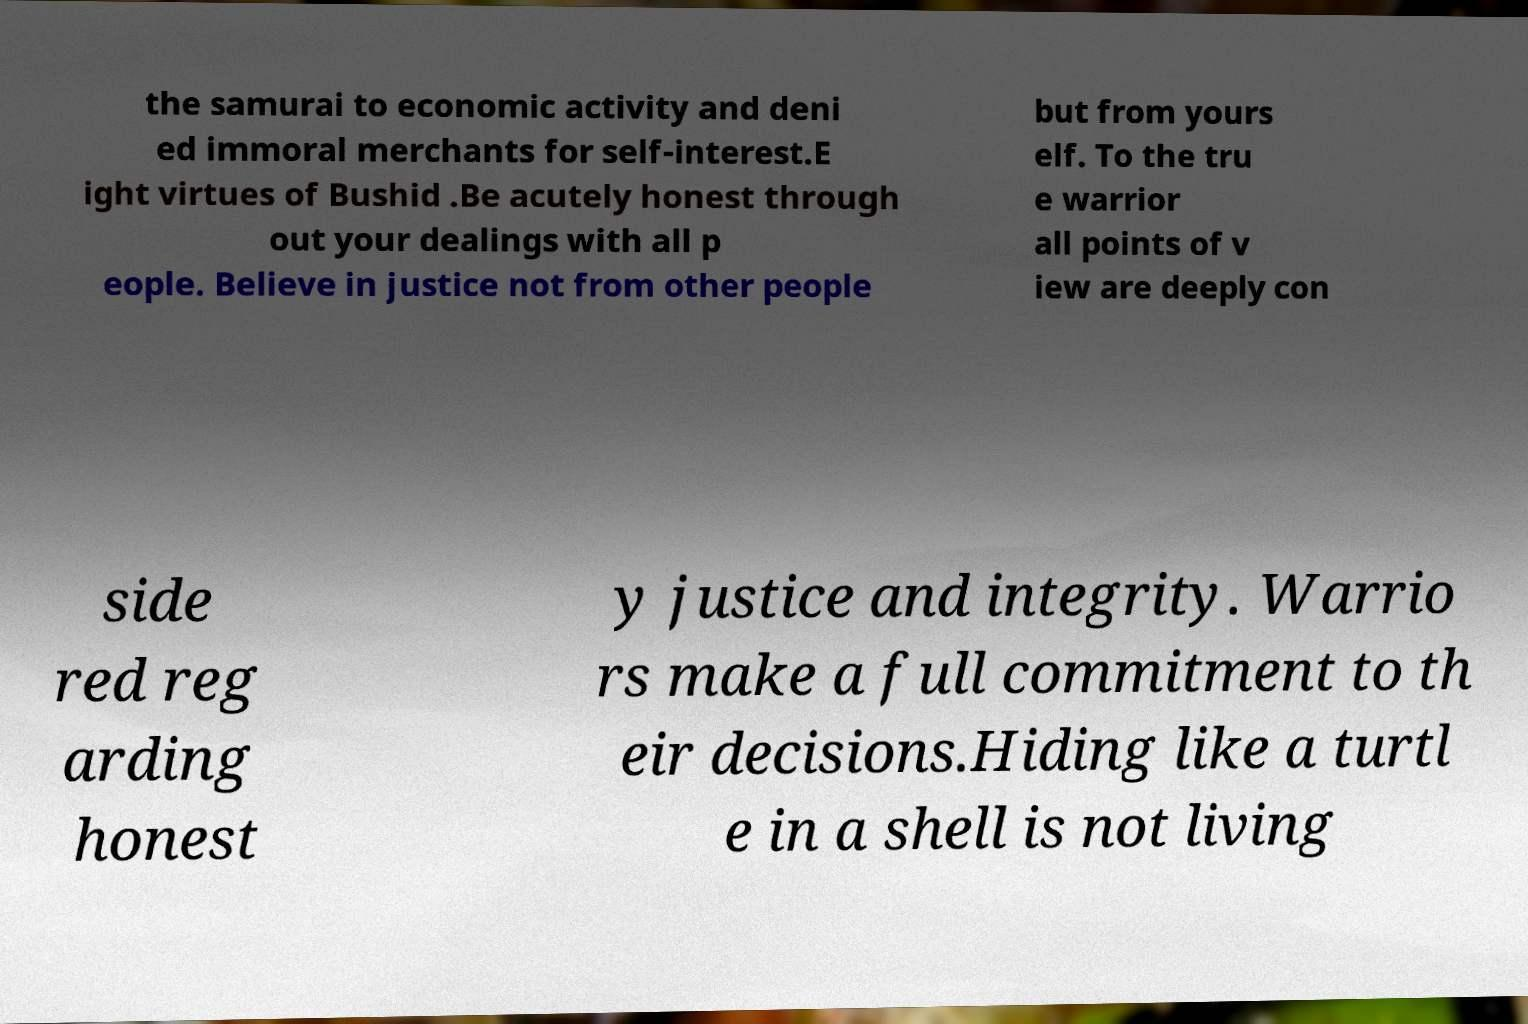Can you read and provide the text displayed in the image?This photo seems to have some interesting text. Can you extract and type it out for me? the samurai to economic activity and deni ed immoral merchants for self-interest.E ight virtues of Bushid .Be acutely honest through out your dealings with all p eople. Believe in justice not from other people but from yours elf. To the tru e warrior all points of v iew are deeply con side red reg arding honest y justice and integrity. Warrio rs make a full commitment to th eir decisions.Hiding like a turtl e in a shell is not living 